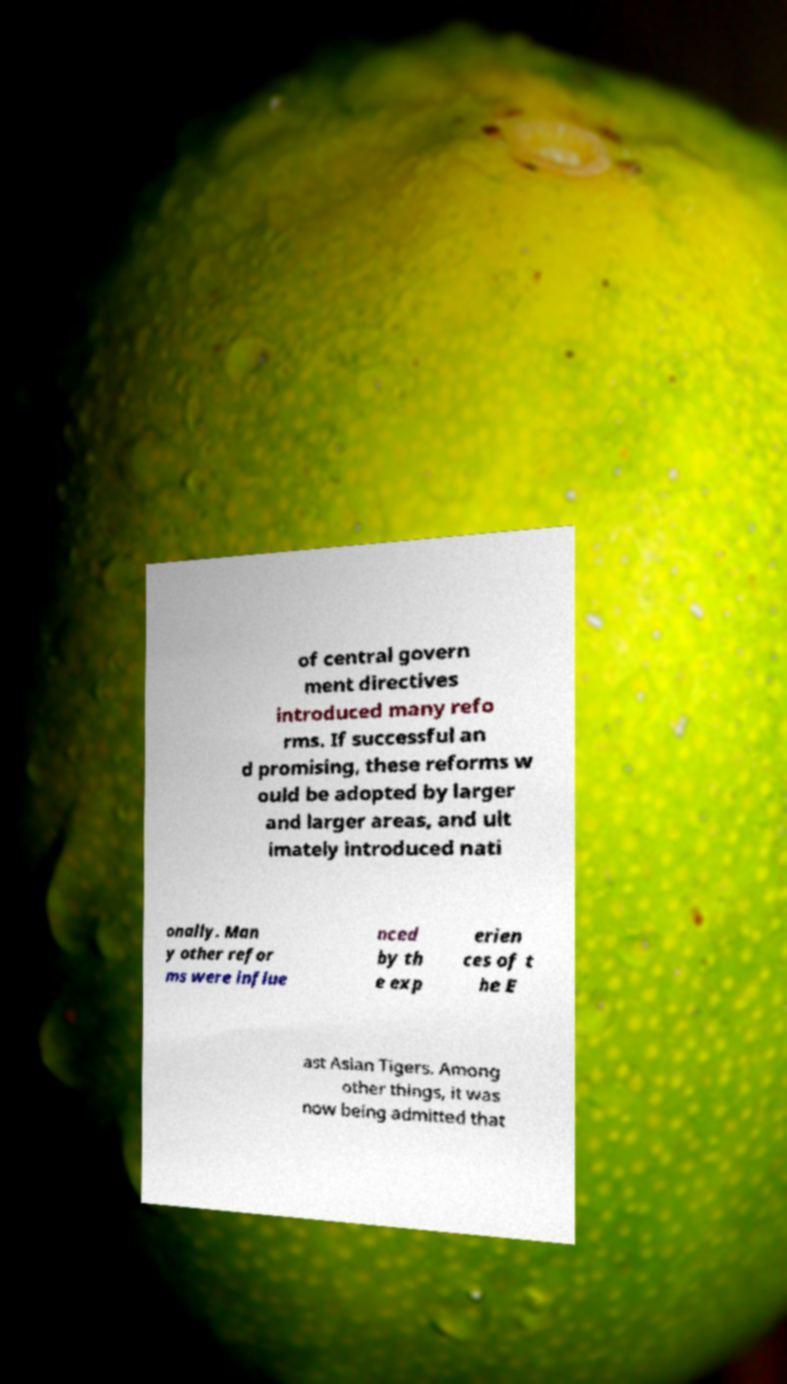Can you read and provide the text displayed in the image?This photo seems to have some interesting text. Can you extract and type it out for me? of central govern ment directives introduced many refo rms. If successful an d promising, these reforms w ould be adopted by larger and larger areas, and ult imately introduced nati onally. Man y other refor ms were influe nced by th e exp erien ces of t he E ast Asian Tigers. Among other things, it was now being admitted that 